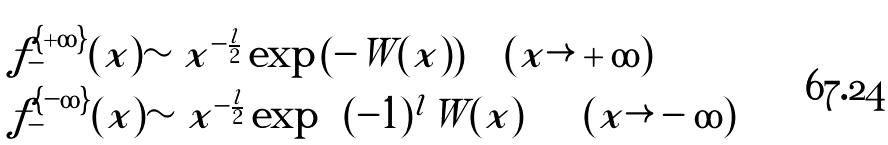<formula> <loc_0><loc_0><loc_500><loc_500>\begin{array} { l l } f _ { - } ^ { \{ + \infty \} } ( x ) \sim x ^ { - \frac { l } { 2 } } \exp \left ( { - W ( x ) } \right ) \quad ( x \rightarrow + \infty ) \\ f _ { - } ^ { \{ - \infty \} } ( x ) \sim x ^ { - \frac { l } { 2 } } \exp \left ( { ( - 1 ) ^ { l } W ( x ) } \right ) \quad ( x \rightarrow - \infty ) \end{array}</formula> 